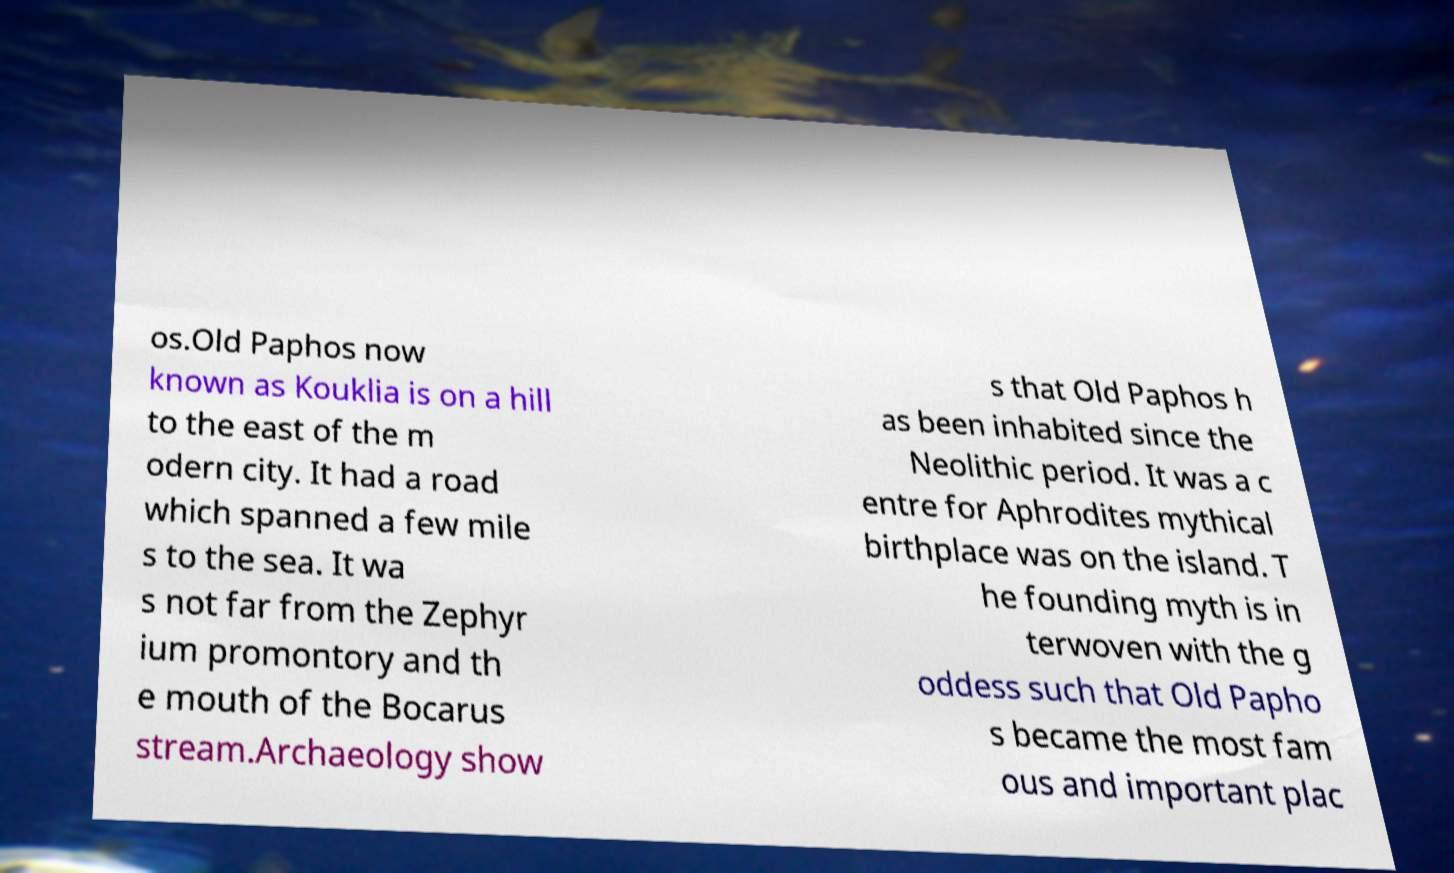Can you accurately transcribe the text from the provided image for me? os.Old Paphos now known as Kouklia is on a hill to the east of the m odern city. It had a road which spanned a few mile s to the sea. It wa s not far from the Zephyr ium promontory and th e mouth of the Bocarus stream.Archaeology show s that Old Paphos h as been inhabited since the Neolithic period. It was a c entre for Aphrodites mythical birthplace was on the island. T he founding myth is in terwoven with the g oddess such that Old Papho s became the most fam ous and important plac 